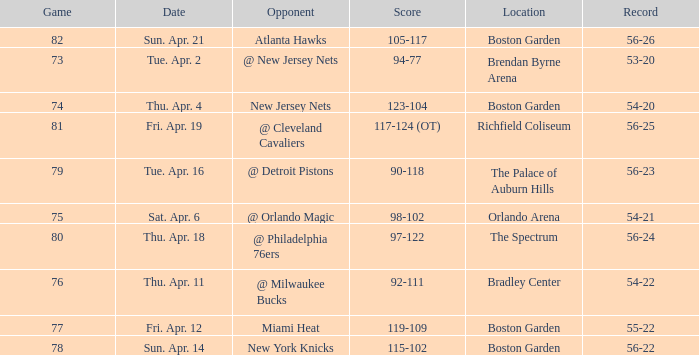Which Score has a Location of richfield coliseum? 117-124 (OT). 